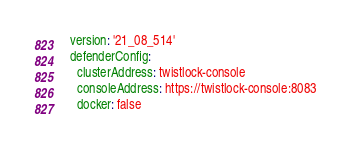Convert code to text. <code><loc_0><loc_0><loc_500><loc_500><_YAML_>  version: '21_08_514'
  defenderConfig:
    clusterAddress: twistlock-console
    consoleAddress: https://twistlock-console:8083
    docker: false
</code> 